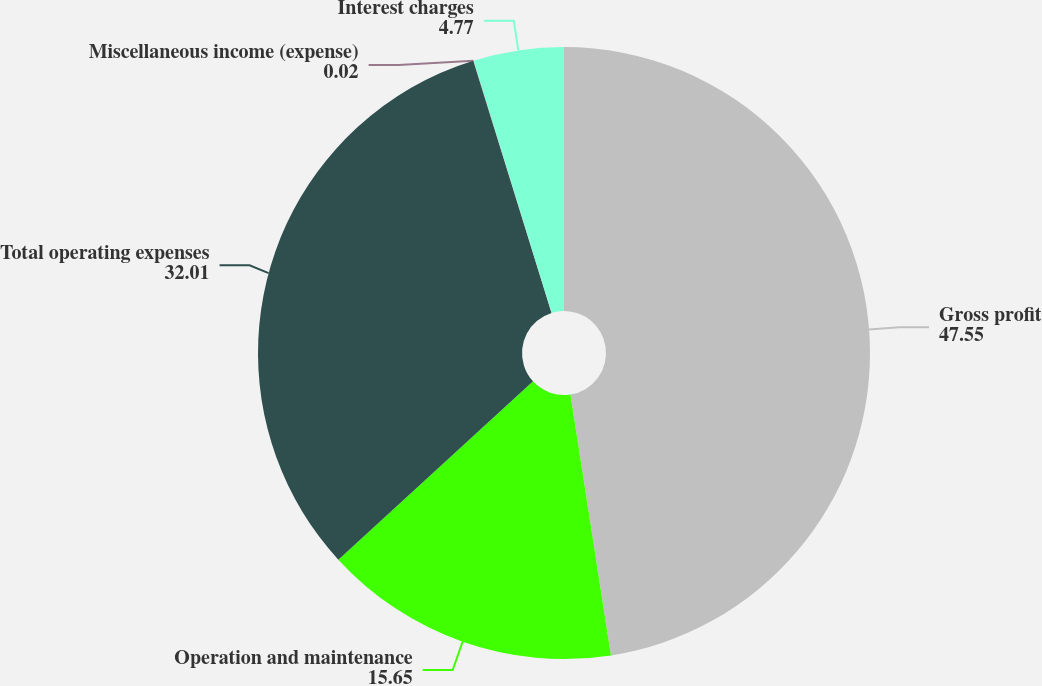Convert chart. <chart><loc_0><loc_0><loc_500><loc_500><pie_chart><fcel>Gross profit<fcel>Operation and maintenance<fcel>Total operating expenses<fcel>Miscellaneous income (expense)<fcel>Interest charges<nl><fcel>47.55%<fcel>15.65%<fcel>32.01%<fcel>0.02%<fcel>4.77%<nl></chart> 